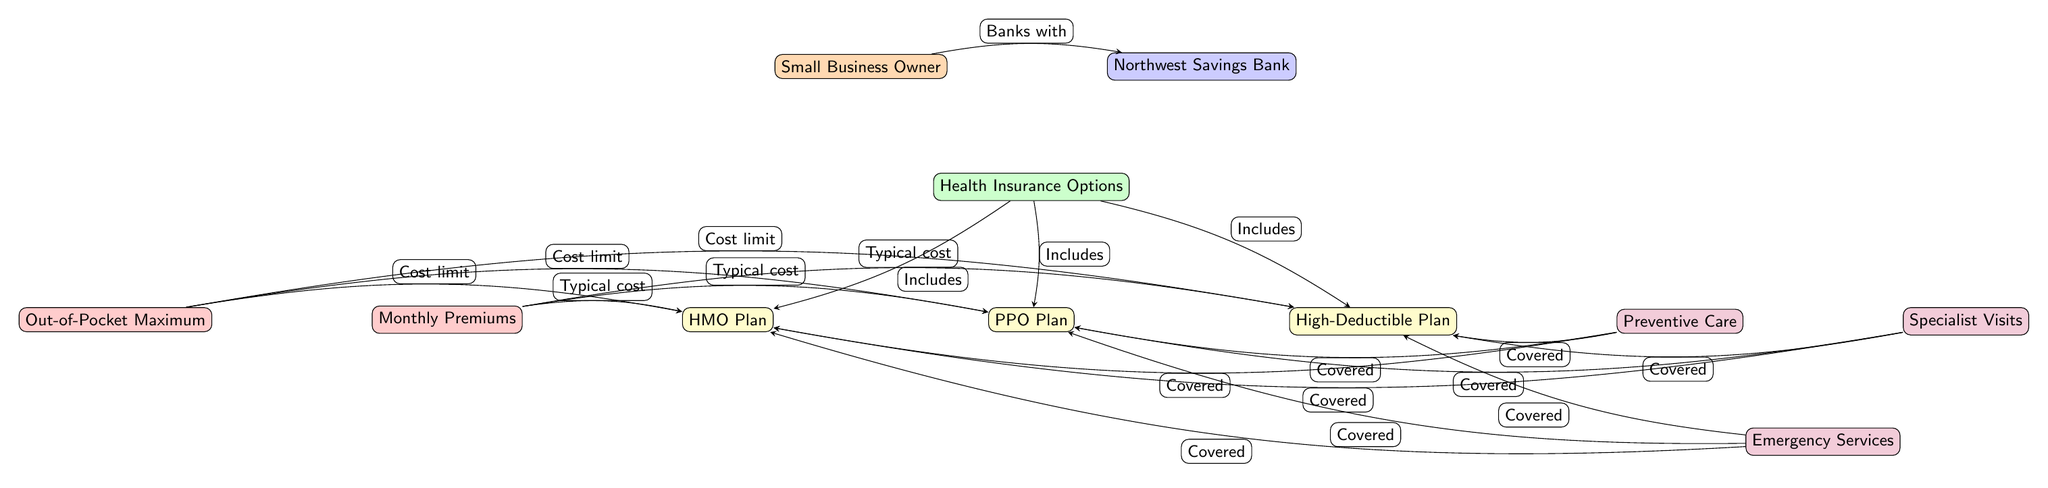What is the primary relationship depicted between the small business owner and Northwest Savings Bank? The diagram shows a directed edge from the small business owner to Northwest Savings Bank with the label "Banks with," indicating the small business owner is associated with or utilizes services from the bank.
Answer: Banks with How many health insurance options are included in the diagram? There are three health insurance options shown in the diagram: HMO Plan, PPO Plan, and High-Deductible Plan, which can be counted directly from the nodes.
Answer: 3 What is the typical cost associated with the HMO plan? The diagram indicates that the cost limits and monthly premiums are related to the HMO plan, but the precise values aren't specified in the visual. However, it's implied to be one of the nodes connected to the typical cost category.
Answer: Typical cost What services are covered under the High-Deductible Plan? The High-Deductible Plan covers preventive care, specialist visits, and emergency services, as indicated by the directed edges connecting these benefit nodes to the High-Deductible Plan node.
Answer: Preventive care, Specialist Visits, Emergency Services What label is found between the small business owner and Northwest Savings Bank? The label on the edge connecting the small business owner to Northwest Savings Bank is "Banks with," which describes their relationship in providing health insurance options.
Answer: Banks with What types of plans are included in the health insurance options? The health insurance options in the diagram include the HMO Plan, PPO Plan, and High-Deductible Plan, which are directly listed as nodes under health insurance options.
Answer: HMO Plan, PPO Plan, High-Deductible Plan What do monthly premiums typically relate to in the context of the insurance plans? Monthly premiums are connected to each insurance plan in the diagram, suggesting that they represent the ongoing cost incurred for each plan, making them a significant financial consideration for each option.
Answer: Cost limit Which benefits are tied to the insurance plans? The benefits connected to the insurance plans include preventive care, specialist visits, and emergency services, as shown in the diagram by directed edges from each insurance plan to the corresponding benefits.
Answer: Preventive Care, Specialist Visits, Emergency Services 